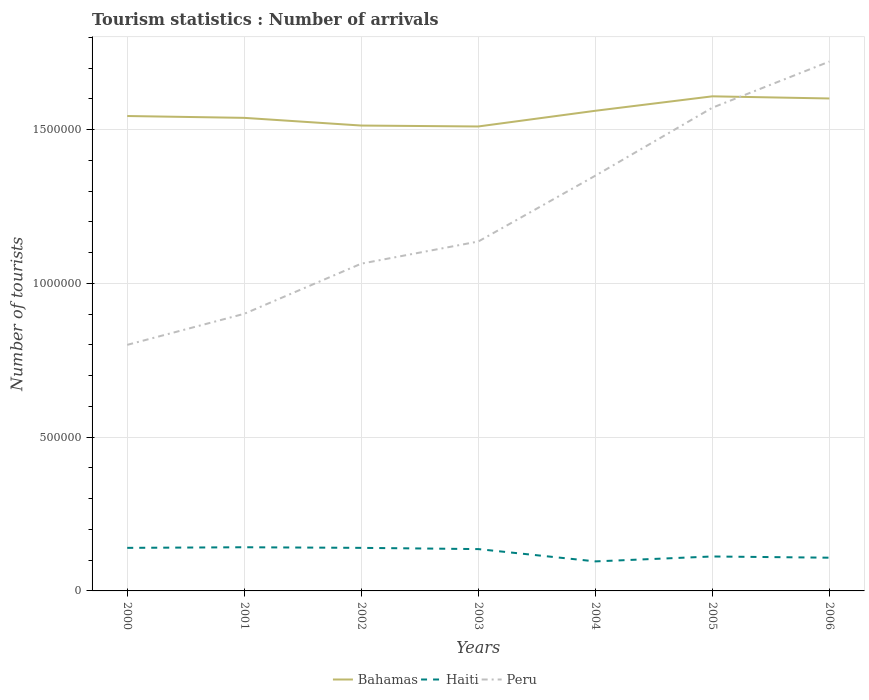How many different coloured lines are there?
Provide a succinct answer. 3. Does the line corresponding to Bahamas intersect with the line corresponding to Peru?
Offer a very short reply. Yes. Across all years, what is the maximum number of tourist arrivals in Haiti?
Offer a terse response. 9.60e+04. What is the total number of tourist arrivals in Bahamas in the graph?
Your response must be concise. -5.70e+04. What is the difference between the highest and the second highest number of tourist arrivals in Bahamas?
Your answer should be very brief. 9.80e+04. What is the difference between the highest and the lowest number of tourist arrivals in Bahamas?
Your answer should be very brief. 3. How many years are there in the graph?
Offer a terse response. 7. What is the difference between two consecutive major ticks on the Y-axis?
Give a very brief answer. 5.00e+05. Are the values on the major ticks of Y-axis written in scientific E-notation?
Make the answer very short. No. What is the title of the graph?
Provide a succinct answer. Tourism statistics : Number of arrivals. Does "Montenegro" appear as one of the legend labels in the graph?
Ensure brevity in your answer.  No. What is the label or title of the X-axis?
Your answer should be compact. Years. What is the label or title of the Y-axis?
Your answer should be compact. Number of tourists. What is the Number of tourists of Bahamas in 2000?
Give a very brief answer. 1.54e+06. What is the Number of tourists of Haiti in 2000?
Make the answer very short. 1.40e+05. What is the Number of tourists in Peru in 2000?
Give a very brief answer. 8.00e+05. What is the Number of tourists of Bahamas in 2001?
Provide a short and direct response. 1.54e+06. What is the Number of tourists in Haiti in 2001?
Your answer should be very brief. 1.42e+05. What is the Number of tourists of Peru in 2001?
Offer a terse response. 9.01e+05. What is the Number of tourists of Bahamas in 2002?
Your response must be concise. 1.51e+06. What is the Number of tourists of Haiti in 2002?
Give a very brief answer. 1.40e+05. What is the Number of tourists of Peru in 2002?
Provide a succinct answer. 1.06e+06. What is the Number of tourists of Bahamas in 2003?
Keep it short and to the point. 1.51e+06. What is the Number of tourists of Haiti in 2003?
Your answer should be very brief. 1.36e+05. What is the Number of tourists of Peru in 2003?
Make the answer very short. 1.14e+06. What is the Number of tourists in Bahamas in 2004?
Your answer should be compact. 1.56e+06. What is the Number of tourists in Haiti in 2004?
Your answer should be very brief. 9.60e+04. What is the Number of tourists in Peru in 2004?
Provide a short and direct response. 1.35e+06. What is the Number of tourists of Bahamas in 2005?
Ensure brevity in your answer.  1.61e+06. What is the Number of tourists of Haiti in 2005?
Ensure brevity in your answer.  1.12e+05. What is the Number of tourists of Peru in 2005?
Provide a succinct answer. 1.57e+06. What is the Number of tourists of Bahamas in 2006?
Your response must be concise. 1.60e+06. What is the Number of tourists of Haiti in 2006?
Keep it short and to the point. 1.08e+05. What is the Number of tourists in Peru in 2006?
Keep it short and to the point. 1.72e+06. Across all years, what is the maximum Number of tourists of Bahamas?
Your answer should be compact. 1.61e+06. Across all years, what is the maximum Number of tourists in Haiti?
Give a very brief answer. 1.42e+05. Across all years, what is the maximum Number of tourists of Peru?
Give a very brief answer. 1.72e+06. Across all years, what is the minimum Number of tourists in Bahamas?
Provide a succinct answer. 1.51e+06. Across all years, what is the minimum Number of tourists in Haiti?
Offer a terse response. 9.60e+04. Across all years, what is the minimum Number of tourists in Peru?
Ensure brevity in your answer.  8.00e+05. What is the total Number of tourists in Bahamas in the graph?
Make the answer very short. 1.09e+07. What is the total Number of tourists of Haiti in the graph?
Your answer should be compact. 8.74e+05. What is the total Number of tourists of Peru in the graph?
Offer a terse response. 8.54e+06. What is the difference between the Number of tourists in Bahamas in 2000 and that in 2001?
Your response must be concise. 6000. What is the difference between the Number of tourists in Haiti in 2000 and that in 2001?
Provide a short and direct response. -2000. What is the difference between the Number of tourists in Peru in 2000 and that in 2001?
Provide a succinct answer. -1.01e+05. What is the difference between the Number of tourists of Bahamas in 2000 and that in 2002?
Your answer should be compact. 3.10e+04. What is the difference between the Number of tourists in Peru in 2000 and that in 2002?
Keep it short and to the point. -2.64e+05. What is the difference between the Number of tourists in Bahamas in 2000 and that in 2003?
Your answer should be compact. 3.40e+04. What is the difference between the Number of tourists in Haiti in 2000 and that in 2003?
Ensure brevity in your answer.  4000. What is the difference between the Number of tourists in Peru in 2000 and that in 2003?
Give a very brief answer. -3.36e+05. What is the difference between the Number of tourists of Bahamas in 2000 and that in 2004?
Your answer should be very brief. -1.70e+04. What is the difference between the Number of tourists of Haiti in 2000 and that in 2004?
Ensure brevity in your answer.  4.40e+04. What is the difference between the Number of tourists in Peru in 2000 and that in 2004?
Provide a short and direct response. -5.50e+05. What is the difference between the Number of tourists of Bahamas in 2000 and that in 2005?
Ensure brevity in your answer.  -6.40e+04. What is the difference between the Number of tourists in Haiti in 2000 and that in 2005?
Your answer should be compact. 2.80e+04. What is the difference between the Number of tourists in Peru in 2000 and that in 2005?
Provide a succinct answer. -7.71e+05. What is the difference between the Number of tourists in Bahamas in 2000 and that in 2006?
Keep it short and to the point. -5.70e+04. What is the difference between the Number of tourists of Haiti in 2000 and that in 2006?
Your answer should be compact. 3.20e+04. What is the difference between the Number of tourists of Peru in 2000 and that in 2006?
Your response must be concise. -9.21e+05. What is the difference between the Number of tourists of Bahamas in 2001 and that in 2002?
Make the answer very short. 2.50e+04. What is the difference between the Number of tourists of Haiti in 2001 and that in 2002?
Keep it short and to the point. 2000. What is the difference between the Number of tourists in Peru in 2001 and that in 2002?
Keep it short and to the point. -1.63e+05. What is the difference between the Number of tourists of Bahamas in 2001 and that in 2003?
Ensure brevity in your answer.  2.80e+04. What is the difference between the Number of tourists in Haiti in 2001 and that in 2003?
Provide a succinct answer. 6000. What is the difference between the Number of tourists in Peru in 2001 and that in 2003?
Provide a succinct answer. -2.35e+05. What is the difference between the Number of tourists in Bahamas in 2001 and that in 2004?
Make the answer very short. -2.30e+04. What is the difference between the Number of tourists in Haiti in 2001 and that in 2004?
Offer a very short reply. 4.60e+04. What is the difference between the Number of tourists in Peru in 2001 and that in 2004?
Your answer should be compact. -4.49e+05. What is the difference between the Number of tourists of Haiti in 2001 and that in 2005?
Offer a very short reply. 3.00e+04. What is the difference between the Number of tourists of Peru in 2001 and that in 2005?
Give a very brief answer. -6.70e+05. What is the difference between the Number of tourists in Bahamas in 2001 and that in 2006?
Provide a succinct answer. -6.30e+04. What is the difference between the Number of tourists in Haiti in 2001 and that in 2006?
Provide a succinct answer. 3.40e+04. What is the difference between the Number of tourists in Peru in 2001 and that in 2006?
Your response must be concise. -8.20e+05. What is the difference between the Number of tourists of Bahamas in 2002 and that in 2003?
Provide a succinct answer. 3000. What is the difference between the Number of tourists in Haiti in 2002 and that in 2003?
Your response must be concise. 4000. What is the difference between the Number of tourists of Peru in 2002 and that in 2003?
Offer a very short reply. -7.20e+04. What is the difference between the Number of tourists in Bahamas in 2002 and that in 2004?
Offer a terse response. -4.80e+04. What is the difference between the Number of tourists of Haiti in 2002 and that in 2004?
Make the answer very short. 4.40e+04. What is the difference between the Number of tourists of Peru in 2002 and that in 2004?
Make the answer very short. -2.86e+05. What is the difference between the Number of tourists of Bahamas in 2002 and that in 2005?
Offer a terse response. -9.50e+04. What is the difference between the Number of tourists in Haiti in 2002 and that in 2005?
Make the answer very short. 2.80e+04. What is the difference between the Number of tourists of Peru in 2002 and that in 2005?
Your response must be concise. -5.07e+05. What is the difference between the Number of tourists of Bahamas in 2002 and that in 2006?
Provide a succinct answer. -8.80e+04. What is the difference between the Number of tourists of Haiti in 2002 and that in 2006?
Ensure brevity in your answer.  3.20e+04. What is the difference between the Number of tourists in Peru in 2002 and that in 2006?
Your answer should be very brief. -6.57e+05. What is the difference between the Number of tourists in Bahamas in 2003 and that in 2004?
Ensure brevity in your answer.  -5.10e+04. What is the difference between the Number of tourists in Haiti in 2003 and that in 2004?
Offer a very short reply. 4.00e+04. What is the difference between the Number of tourists of Peru in 2003 and that in 2004?
Offer a very short reply. -2.14e+05. What is the difference between the Number of tourists of Bahamas in 2003 and that in 2005?
Make the answer very short. -9.80e+04. What is the difference between the Number of tourists of Haiti in 2003 and that in 2005?
Your response must be concise. 2.40e+04. What is the difference between the Number of tourists in Peru in 2003 and that in 2005?
Provide a succinct answer. -4.35e+05. What is the difference between the Number of tourists in Bahamas in 2003 and that in 2006?
Provide a succinct answer. -9.10e+04. What is the difference between the Number of tourists in Haiti in 2003 and that in 2006?
Your answer should be compact. 2.80e+04. What is the difference between the Number of tourists in Peru in 2003 and that in 2006?
Provide a succinct answer. -5.85e+05. What is the difference between the Number of tourists of Bahamas in 2004 and that in 2005?
Your answer should be very brief. -4.70e+04. What is the difference between the Number of tourists of Haiti in 2004 and that in 2005?
Offer a very short reply. -1.60e+04. What is the difference between the Number of tourists of Peru in 2004 and that in 2005?
Your response must be concise. -2.21e+05. What is the difference between the Number of tourists of Haiti in 2004 and that in 2006?
Make the answer very short. -1.20e+04. What is the difference between the Number of tourists in Peru in 2004 and that in 2006?
Provide a short and direct response. -3.71e+05. What is the difference between the Number of tourists in Bahamas in 2005 and that in 2006?
Provide a short and direct response. 7000. What is the difference between the Number of tourists of Haiti in 2005 and that in 2006?
Ensure brevity in your answer.  4000. What is the difference between the Number of tourists of Peru in 2005 and that in 2006?
Offer a terse response. -1.50e+05. What is the difference between the Number of tourists of Bahamas in 2000 and the Number of tourists of Haiti in 2001?
Give a very brief answer. 1.40e+06. What is the difference between the Number of tourists in Bahamas in 2000 and the Number of tourists in Peru in 2001?
Your response must be concise. 6.43e+05. What is the difference between the Number of tourists of Haiti in 2000 and the Number of tourists of Peru in 2001?
Give a very brief answer. -7.61e+05. What is the difference between the Number of tourists in Bahamas in 2000 and the Number of tourists in Haiti in 2002?
Ensure brevity in your answer.  1.40e+06. What is the difference between the Number of tourists in Bahamas in 2000 and the Number of tourists in Peru in 2002?
Give a very brief answer. 4.80e+05. What is the difference between the Number of tourists in Haiti in 2000 and the Number of tourists in Peru in 2002?
Provide a succinct answer. -9.24e+05. What is the difference between the Number of tourists in Bahamas in 2000 and the Number of tourists in Haiti in 2003?
Your response must be concise. 1.41e+06. What is the difference between the Number of tourists in Bahamas in 2000 and the Number of tourists in Peru in 2003?
Your response must be concise. 4.08e+05. What is the difference between the Number of tourists in Haiti in 2000 and the Number of tourists in Peru in 2003?
Keep it short and to the point. -9.96e+05. What is the difference between the Number of tourists of Bahamas in 2000 and the Number of tourists of Haiti in 2004?
Make the answer very short. 1.45e+06. What is the difference between the Number of tourists of Bahamas in 2000 and the Number of tourists of Peru in 2004?
Your answer should be compact. 1.94e+05. What is the difference between the Number of tourists in Haiti in 2000 and the Number of tourists in Peru in 2004?
Keep it short and to the point. -1.21e+06. What is the difference between the Number of tourists in Bahamas in 2000 and the Number of tourists in Haiti in 2005?
Your answer should be very brief. 1.43e+06. What is the difference between the Number of tourists in Bahamas in 2000 and the Number of tourists in Peru in 2005?
Make the answer very short. -2.70e+04. What is the difference between the Number of tourists in Haiti in 2000 and the Number of tourists in Peru in 2005?
Keep it short and to the point. -1.43e+06. What is the difference between the Number of tourists of Bahamas in 2000 and the Number of tourists of Haiti in 2006?
Your response must be concise. 1.44e+06. What is the difference between the Number of tourists of Bahamas in 2000 and the Number of tourists of Peru in 2006?
Give a very brief answer. -1.77e+05. What is the difference between the Number of tourists in Haiti in 2000 and the Number of tourists in Peru in 2006?
Make the answer very short. -1.58e+06. What is the difference between the Number of tourists of Bahamas in 2001 and the Number of tourists of Haiti in 2002?
Provide a succinct answer. 1.40e+06. What is the difference between the Number of tourists in Bahamas in 2001 and the Number of tourists in Peru in 2002?
Ensure brevity in your answer.  4.74e+05. What is the difference between the Number of tourists in Haiti in 2001 and the Number of tourists in Peru in 2002?
Provide a succinct answer. -9.22e+05. What is the difference between the Number of tourists in Bahamas in 2001 and the Number of tourists in Haiti in 2003?
Your answer should be compact. 1.40e+06. What is the difference between the Number of tourists of Bahamas in 2001 and the Number of tourists of Peru in 2003?
Your answer should be very brief. 4.02e+05. What is the difference between the Number of tourists in Haiti in 2001 and the Number of tourists in Peru in 2003?
Keep it short and to the point. -9.94e+05. What is the difference between the Number of tourists in Bahamas in 2001 and the Number of tourists in Haiti in 2004?
Give a very brief answer. 1.44e+06. What is the difference between the Number of tourists in Bahamas in 2001 and the Number of tourists in Peru in 2004?
Offer a very short reply. 1.88e+05. What is the difference between the Number of tourists of Haiti in 2001 and the Number of tourists of Peru in 2004?
Offer a terse response. -1.21e+06. What is the difference between the Number of tourists of Bahamas in 2001 and the Number of tourists of Haiti in 2005?
Offer a terse response. 1.43e+06. What is the difference between the Number of tourists in Bahamas in 2001 and the Number of tourists in Peru in 2005?
Give a very brief answer. -3.30e+04. What is the difference between the Number of tourists in Haiti in 2001 and the Number of tourists in Peru in 2005?
Keep it short and to the point. -1.43e+06. What is the difference between the Number of tourists of Bahamas in 2001 and the Number of tourists of Haiti in 2006?
Give a very brief answer. 1.43e+06. What is the difference between the Number of tourists in Bahamas in 2001 and the Number of tourists in Peru in 2006?
Offer a very short reply. -1.83e+05. What is the difference between the Number of tourists in Haiti in 2001 and the Number of tourists in Peru in 2006?
Make the answer very short. -1.58e+06. What is the difference between the Number of tourists in Bahamas in 2002 and the Number of tourists in Haiti in 2003?
Offer a very short reply. 1.38e+06. What is the difference between the Number of tourists of Bahamas in 2002 and the Number of tourists of Peru in 2003?
Offer a very short reply. 3.77e+05. What is the difference between the Number of tourists in Haiti in 2002 and the Number of tourists in Peru in 2003?
Your answer should be very brief. -9.96e+05. What is the difference between the Number of tourists of Bahamas in 2002 and the Number of tourists of Haiti in 2004?
Your response must be concise. 1.42e+06. What is the difference between the Number of tourists of Bahamas in 2002 and the Number of tourists of Peru in 2004?
Provide a succinct answer. 1.63e+05. What is the difference between the Number of tourists of Haiti in 2002 and the Number of tourists of Peru in 2004?
Keep it short and to the point. -1.21e+06. What is the difference between the Number of tourists in Bahamas in 2002 and the Number of tourists in Haiti in 2005?
Keep it short and to the point. 1.40e+06. What is the difference between the Number of tourists in Bahamas in 2002 and the Number of tourists in Peru in 2005?
Give a very brief answer. -5.80e+04. What is the difference between the Number of tourists of Haiti in 2002 and the Number of tourists of Peru in 2005?
Provide a succinct answer. -1.43e+06. What is the difference between the Number of tourists in Bahamas in 2002 and the Number of tourists in Haiti in 2006?
Your answer should be very brief. 1.40e+06. What is the difference between the Number of tourists in Bahamas in 2002 and the Number of tourists in Peru in 2006?
Keep it short and to the point. -2.08e+05. What is the difference between the Number of tourists of Haiti in 2002 and the Number of tourists of Peru in 2006?
Ensure brevity in your answer.  -1.58e+06. What is the difference between the Number of tourists of Bahamas in 2003 and the Number of tourists of Haiti in 2004?
Your response must be concise. 1.41e+06. What is the difference between the Number of tourists in Haiti in 2003 and the Number of tourists in Peru in 2004?
Offer a very short reply. -1.21e+06. What is the difference between the Number of tourists of Bahamas in 2003 and the Number of tourists of Haiti in 2005?
Your response must be concise. 1.40e+06. What is the difference between the Number of tourists in Bahamas in 2003 and the Number of tourists in Peru in 2005?
Make the answer very short. -6.10e+04. What is the difference between the Number of tourists in Haiti in 2003 and the Number of tourists in Peru in 2005?
Make the answer very short. -1.44e+06. What is the difference between the Number of tourists of Bahamas in 2003 and the Number of tourists of Haiti in 2006?
Offer a terse response. 1.40e+06. What is the difference between the Number of tourists in Bahamas in 2003 and the Number of tourists in Peru in 2006?
Your response must be concise. -2.11e+05. What is the difference between the Number of tourists of Haiti in 2003 and the Number of tourists of Peru in 2006?
Your response must be concise. -1.58e+06. What is the difference between the Number of tourists of Bahamas in 2004 and the Number of tourists of Haiti in 2005?
Make the answer very short. 1.45e+06. What is the difference between the Number of tourists in Bahamas in 2004 and the Number of tourists in Peru in 2005?
Offer a terse response. -10000. What is the difference between the Number of tourists of Haiti in 2004 and the Number of tourists of Peru in 2005?
Your answer should be very brief. -1.48e+06. What is the difference between the Number of tourists in Bahamas in 2004 and the Number of tourists in Haiti in 2006?
Provide a succinct answer. 1.45e+06. What is the difference between the Number of tourists of Haiti in 2004 and the Number of tourists of Peru in 2006?
Keep it short and to the point. -1.62e+06. What is the difference between the Number of tourists of Bahamas in 2005 and the Number of tourists of Haiti in 2006?
Your response must be concise. 1.50e+06. What is the difference between the Number of tourists in Bahamas in 2005 and the Number of tourists in Peru in 2006?
Offer a very short reply. -1.13e+05. What is the difference between the Number of tourists in Haiti in 2005 and the Number of tourists in Peru in 2006?
Your answer should be compact. -1.61e+06. What is the average Number of tourists in Bahamas per year?
Provide a succinct answer. 1.55e+06. What is the average Number of tourists in Haiti per year?
Provide a succinct answer. 1.25e+05. What is the average Number of tourists in Peru per year?
Give a very brief answer. 1.22e+06. In the year 2000, what is the difference between the Number of tourists in Bahamas and Number of tourists in Haiti?
Give a very brief answer. 1.40e+06. In the year 2000, what is the difference between the Number of tourists in Bahamas and Number of tourists in Peru?
Your response must be concise. 7.44e+05. In the year 2000, what is the difference between the Number of tourists of Haiti and Number of tourists of Peru?
Provide a succinct answer. -6.60e+05. In the year 2001, what is the difference between the Number of tourists in Bahamas and Number of tourists in Haiti?
Ensure brevity in your answer.  1.40e+06. In the year 2001, what is the difference between the Number of tourists in Bahamas and Number of tourists in Peru?
Provide a succinct answer. 6.37e+05. In the year 2001, what is the difference between the Number of tourists of Haiti and Number of tourists of Peru?
Make the answer very short. -7.59e+05. In the year 2002, what is the difference between the Number of tourists of Bahamas and Number of tourists of Haiti?
Keep it short and to the point. 1.37e+06. In the year 2002, what is the difference between the Number of tourists of Bahamas and Number of tourists of Peru?
Give a very brief answer. 4.49e+05. In the year 2002, what is the difference between the Number of tourists in Haiti and Number of tourists in Peru?
Provide a short and direct response. -9.24e+05. In the year 2003, what is the difference between the Number of tourists in Bahamas and Number of tourists in Haiti?
Make the answer very short. 1.37e+06. In the year 2003, what is the difference between the Number of tourists of Bahamas and Number of tourists of Peru?
Offer a terse response. 3.74e+05. In the year 2004, what is the difference between the Number of tourists of Bahamas and Number of tourists of Haiti?
Your response must be concise. 1.46e+06. In the year 2004, what is the difference between the Number of tourists of Bahamas and Number of tourists of Peru?
Your response must be concise. 2.11e+05. In the year 2004, what is the difference between the Number of tourists in Haiti and Number of tourists in Peru?
Give a very brief answer. -1.25e+06. In the year 2005, what is the difference between the Number of tourists of Bahamas and Number of tourists of Haiti?
Your answer should be compact. 1.50e+06. In the year 2005, what is the difference between the Number of tourists of Bahamas and Number of tourists of Peru?
Your response must be concise. 3.70e+04. In the year 2005, what is the difference between the Number of tourists of Haiti and Number of tourists of Peru?
Offer a very short reply. -1.46e+06. In the year 2006, what is the difference between the Number of tourists of Bahamas and Number of tourists of Haiti?
Give a very brief answer. 1.49e+06. In the year 2006, what is the difference between the Number of tourists of Haiti and Number of tourists of Peru?
Keep it short and to the point. -1.61e+06. What is the ratio of the Number of tourists in Haiti in 2000 to that in 2001?
Your answer should be compact. 0.99. What is the ratio of the Number of tourists in Peru in 2000 to that in 2001?
Offer a very short reply. 0.89. What is the ratio of the Number of tourists in Bahamas in 2000 to that in 2002?
Your response must be concise. 1.02. What is the ratio of the Number of tourists of Peru in 2000 to that in 2002?
Keep it short and to the point. 0.75. What is the ratio of the Number of tourists in Bahamas in 2000 to that in 2003?
Give a very brief answer. 1.02. What is the ratio of the Number of tourists of Haiti in 2000 to that in 2003?
Ensure brevity in your answer.  1.03. What is the ratio of the Number of tourists of Peru in 2000 to that in 2003?
Your response must be concise. 0.7. What is the ratio of the Number of tourists of Bahamas in 2000 to that in 2004?
Provide a succinct answer. 0.99. What is the ratio of the Number of tourists of Haiti in 2000 to that in 2004?
Provide a short and direct response. 1.46. What is the ratio of the Number of tourists of Peru in 2000 to that in 2004?
Your response must be concise. 0.59. What is the ratio of the Number of tourists in Bahamas in 2000 to that in 2005?
Offer a terse response. 0.96. What is the ratio of the Number of tourists of Peru in 2000 to that in 2005?
Your response must be concise. 0.51. What is the ratio of the Number of tourists in Bahamas in 2000 to that in 2006?
Provide a succinct answer. 0.96. What is the ratio of the Number of tourists of Haiti in 2000 to that in 2006?
Provide a succinct answer. 1.3. What is the ratio of the Number of tourists in Peru in 2000 to that in 2006?
Your answer should be very brief. 0.46. What is the ratio of the Number of tourists in Bahamas in 2001 to that in 2002?
Provide a succinct answer. 1.02. What is the ratio of the Number of tourists of Haiti in 2001 to that in 2002?
Offer a very short reply. 1.01. What is the ratio of the Number of tourists in Peru in 2001 to that in 2002?
Provide a succinct answer. 0.85. What is the ratio of the Number of tourists of Bahamas in 2001 to that in 2003?
Make the answer very short. 1.02. What is the ratio of the Number of tourists of Haiti in 2001 to that in 2003?
Your response must be concise. 1.04. What is the ratio of the Number of tourists of Peru in 2001 to that in 2003?
Ensure brevity in your answer.  0.79. What is the ratio of the Number of tourists of Bahamas in 2001 to that in 2004?
Offer a very short reply. 0.99. What is the ratio of the Number of tourists in Haiti in 2001 to that in 2004?
Provide a succinct answer. 1.48. What is the ratio of the Number of tourists of Peru in 2001 to that in 2004?
Offer a very short reply. 0.67. What is the ratio of the Number of tourists of Bahamas in 2001 to that in 2005?
Ensure brevity in your answer.  0.96. What is the ratio of the Number of tourists in Haiti in 2001 to that in 2005?
Ensure brevity in your answer.  1.27. What is the ratio of the Number of tourists of Peru in 2001 to that in 2005?
Ensure brevity in your answer.  0.57. What is the ratio of the Number of tourists in Bahamas in 2001 to that in 2006?
Your answer should be very brief. 0.96. What is the ratio of the Number of tourists of Haiti in 2001 to that in 2006?
Offer a very short reply. 1.31. What is the ratio of the Number of tourists in Peru in 2001 to that in 2006?
Provide a succinct answer. 0.52. What is the ratio of the Number of tourists in Bahamas in 2002 to that in 2003?
Offer a terse response. 1. What is the ratio of the Number of tourists in Haiti in 2002 to that in 2003?
Give a very brief answer. 1.03. What is the ratio of the Number of tourists of Peru in 2002 to that in 2003?
Keep it short and to the point. 0.94. What is the ratio of the Number of tourists of Bahamas in 2002 to that in 2004?
Your response must be concise. 0.97. What is the ratio of the Number of tourists in Haiti in 2002 to that in 2004?
Your response must be concise. 1.46. What is the ratio of the Number of tourists of Peru in 2002 to that in 2004?
Your answer should be very brief. 0.79. What is the ratio of the Number of tourists of Bahamas in 2002 to that in 2005?
Provide a succinct answer. 0.94. What is the ratio of the Number of tourists of Peru in 2002 to that in 2005?
Keep it short and to the point. 0.68. What is the ratio of the Number of tourists of Bahamas in 2002 to that in 2006?
Offer a very short reply. 0.94. What is the ratio of the Number of tourists in Haiti in 2002 to that in 2006?
Keep it short and to the point. 1.3. What is the ratio of the Number of tourists of Peru in 2002 to that in 2006?
Ensure brevity in your answer.  0.62. What is the ratio of the Number of tourists of Bahamas in 2003 to that in 2004?
Offer a terse response. 0.97. What is the ratio of the Number of tourists in Haiti in 2003 to that in 2004?
Make the answer very short. 1.42. What is the ratio of the Number of tourists of Peru in 2003 to that in 2004?
Offer a very short reply. 0.84. What is the ratio of the Number of tourists of Bahamas in 2003 to that in 2005?
Offer a very short reply. 0.94. What is the ratio of the Number of tourists of Haiti in 2003 to that in 2005?
Offer a terse response. 1.21. What is the ratio of the Number of tourists in Peru in 2003 to that in 2005?
Your answer should be very brief. 0.72. What is the ratio of the Number of tourists in Bahamas in 2003 to that in 2006?
Your answer should be very brief. 0.94. What is the ratio of the Number of tourists in Haiti in 2003 to that in 2006?
Provide a short and direct response. 1.26. What is the ratio of the Number of tourists in Peru in 2003 to that in 2006?
Give a very brief answer. 0.66. What is the ratio of the Number of tourists in Bahamas in 2004 to that in 2005?
Offer a terse response. 0.97. What is the ratio of the Number of tourists in Peru in 2004 to that in 2005?
Offer a very short reply. 0.86. What is the ratio of the Number of tourists in Bahamas in 2004 to that in 2006?
Keep it short and to the point. 0.97. What is the ratio of the Number of tourists in Haiti in 2004 to that in 2006?
Provide a succinct answer. 0.89. What is the ratio of the Number of tourists in Peru in 2004 to that in 2006?
Your answer should be compact. 0.78. What is the ratio of the Number of tourists of Bahamas in 2005 to that in 2006?
Your response must be concise. 1. What is the ratio of the Number of tourists of Haiti in 2005 to that in 2006?
Provide a short and direct response. 1.04. What is the ratio of the Number of tourists of Peru in 2005 to that in 2006?
Your answer should be very brief. 0.91. What is the difference between the highest and the second highest Number of tourists of Bahamas?
Provide a short and direct response. 7000. What is the difference between the highest and the second highest Number of tourists of Haiti?
Provide a short and direct response. 2000. What is the difference between the highest and the second highest Number of tourists in Peru?
Make the answer very short. 1.50e+05. What is the difference between the highest and the lowest Number of tourists in Bahamas?
Ensure brevity in your answer.  9.80e+04. What is the difference between the highest and the lowest Number of tourists of Haiti?
Give a very brief answer. 4.60e+04. What is the difference between the highest and the lowest Number of tourists of Peru?
Your answer should be very brief. 9.21e+05. 